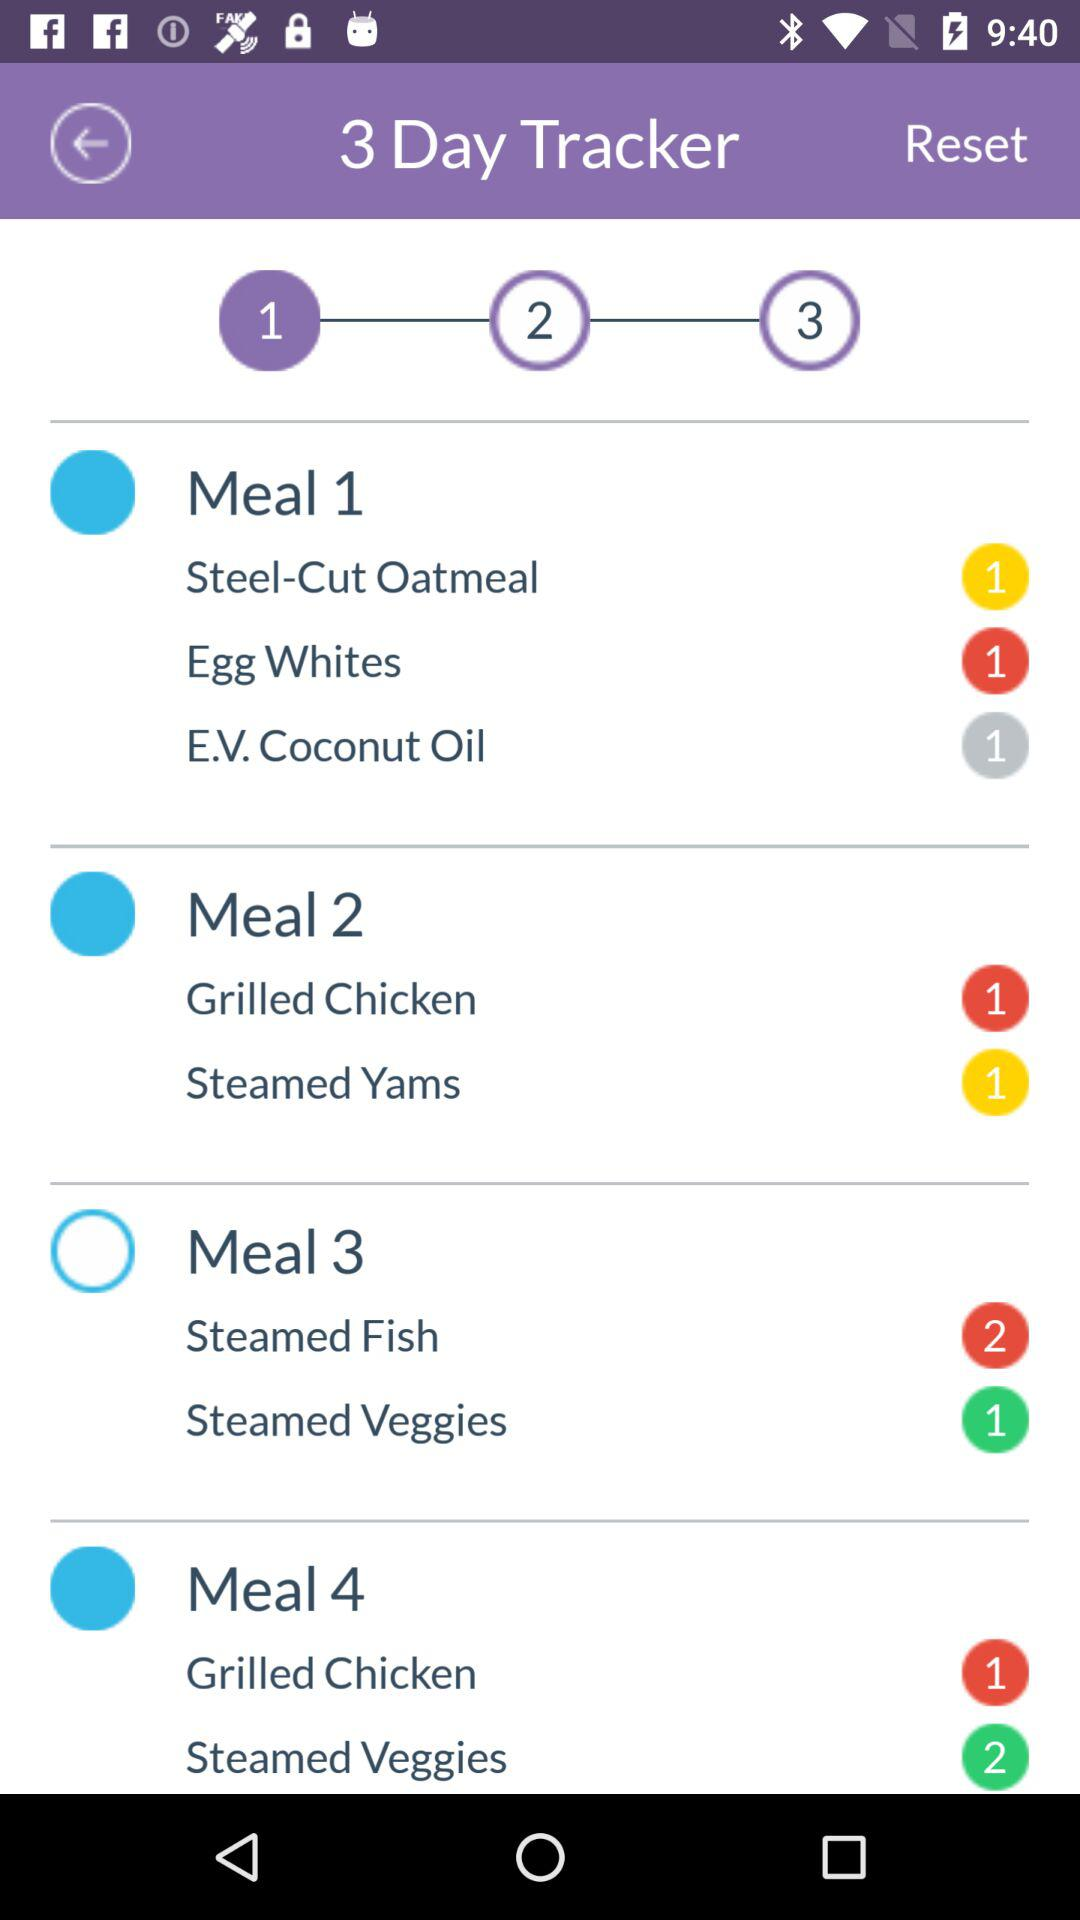How many meals are there in the first day?
Answer the question using a single word or phrase. 3 